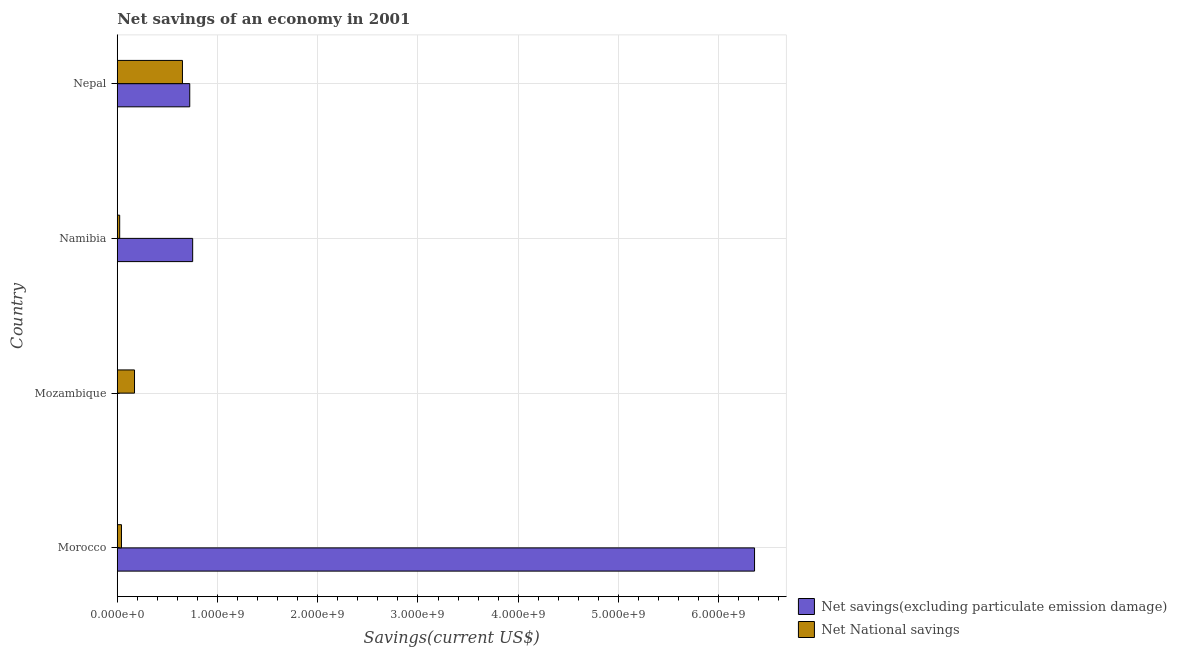Are the number of bars per tick equal to the number of legend labels?
Offer a very short reply. No. Are the number of bars on each tick of the Y-axis equal?
Make the answer very short. No. How many bars are there on the 1st tick from the bottom?
Your answer should be very brief. 2. What is the label of the 2nd group of bars from the top?
Ensure brevity in your answer.  Namibia. In how many cases, is the number of bars for a given country not equal to the number of legend labels?
Your response must be concise. 1. Across all countries, what is the maximum net savings(excluding particulate emission damage)?
Your response must be concise. 6.36e+09. Across all countries, what is the minimum net national savings?
Keep it short and to the point. 2.40e+07. In which country was the net national savings maximum?
Provide a succinct answer. Nepal. What is the total net savings(excluding particulate emission damage) in the graph?
Offer a terse response. 7.83e+09. What is the difference between the net national savings in Mozambique and that in Nepal?
Provide a short and direct response. -4.78e+08. What is the difference between the net savings(excluding particulate emission damage) in Namibia and the net national savings in Morocco?
Offer a very short reply. 7.11e+08. What is the average net savings(excluding particulate emission damage) per country?
Your answer should be very brief. 1.96e+09. What is the difference between the net savings(excluding particulate emission damage) and net national savings in Morocco?
Your response must be concise. 6.32e+09. What is the ratio of the net national savings in Namibia to that in Nepal?
Ensure brevity in your answer.  0.04. Is the difference between the net savings(excluding particulate emission damage) in Namibia and Nepal greater than the difference between the net national savings in Namibia and Nepal?
Provide a short and direct response. Yes. What is the difference between the highest and the second highest net national savings?
Your response must be concise. 4.78e+08. What is the difference between the highest and the lowest net savings(excluding particulate emission damage)?
Your response must be concise. 6.36e+09. Is the sum of the net national savings in Mozambique and Nepal greater than the maximum net savings(excluding particulate emission damage) across all countries?
Offer a very short reply. No. How many countries are there in the graph?
Your answer should be very brief. 4. What is the difference between two consecutive major ticks on the X-axis?
Your response must be concise. 1.00e+09. Are the values on the major ticks of X-axis written in scientific E-notation?
Your answer should be very brief. Yes. Where does the legend appear in the graph?
Keep it short and to the point. Bottom right. How many legend labels are there?
Your answer should be very brief. 2. How are the legend labels stacked?
Provide a short and direct response. Vertical. What is the title of the graph?
Make the answer very short. Net savings of an economy in 2001. Does "Foreign liabilities" appear as one of the legend labels in the graph?
Your response must be concise. No. What is the label or title of the X-axis?
Keep it short and to the point. Savings(current US$). What is the Savings(current US$) of Net savings(excluding particulate emission damage) in Morocco?
Your response must be concise. 6.36e+09. What is the Savings(current US$) of Net National savings in Morocco?
Give a very brief answer. 4.17e+07. What is the Savings(current US$) of Net savings(excluding particulate emission damage) in Mozambique?
Give a very brief answer. 0. What is the Savings(current US$) in Net National savings in Mozambique?
Your response must be concise. 1.72e+08. What is the Savings(current US$) in Net savings(excluding particulate emission damage) in Namibia?
Provide a short and direct response. 7.52e+08. What is the Savings(current US$) in Net National savings in Namibia?
Provide a short and direct response. 2.40e+07. What is the Savings(current US$) in Net savings(excluding particulate emission damage) in Nepal?
Your response must be concise. 7.23e+08. What is the Savings(current US$) of Net National savings in Nepal?
Ensure brevity in your answer.  6.50e+08. Across all countries, what is the maximum Savings(current US$) in Net savings(excluding particulate emission damage)?
Provide a succinct answer. 6.36e+09. Across all countries, what is the maximum Savings(current US$) of Net National savings?
Offer a very short reply. 6.50e+08. Across all countries, what is the minimum Savings(current US$) of Net National savings?
Give a very brief answer. 2.40e+07. What is the total Savings(current US$) in Net savings(excluding particulate emission damage) in the graph?
Keep it short and to the point. 7.83e+09. What is the total Savings(current US$) in Net National savings in the graph?
Ensure brevity in your answer.  8.88e+08. What is the difference between the Savings(current US$) in Net National savings in Morocco and that in Mozambique?
Your response must be concise. -1.30e+08. What is the difference between the Savings(current US$) of Net savings(excluding particulate emission damage) in Morocco and that in Namibia?
Offer a very short reply. 5.61e+09. What is the difference between the Savings(current US$) in Net National savings in Morocco and that in Namibia?
Provide a short and direct response. 1.77e+07. What is the difference between the Savings(current US$) of Net savings(excluding particulate emission damage) in Morocco and that in Nepal?
Provide a succinct answer. 5.64e+09. What is the difference between the Savings(current US$) in Net National savings in Morocco and that in Nepal?
Make the answer very short. -6.08e+08. What is the difference between the Savings(current US$) in Net National savings in Mozambique and that in Namibia?
Make the answer very short. 1.48e+08. What is the difference between the Savings(current US$) in Net National savings in Mozambique and that in Nepal?
Make the answer very short. -4.78e+08. What is the difference between the Savings(current US$) in Net savings(excluding particulate emission damage) in Namibia and that in Nepal?
Your answer should be compact. 2.92e+07. What is the difference between the Savings(current US$) of Net National savings in Namibia and that in Nepal?
Make the answer very short. -6.26e+08. What is the difference between the Savings(current US$) in Net savings(excluding particulate emission damage) in Morocco and the Savings(current US$) in Net National savings in Mozambique?
Keep it short and to the point. 6.19e+09. What is the difference between the Savings(current US$) in Net savings(excluding particulate emission damage) in Morocco and the Savings(current US$) in Net National savings in Namibia?
Give a very brief answer. 6.33e+09. What is the difference between the Savings(current US$) in Net savings(excluding particulate emission damage) in Morocco and the Savings(current US$) in Net National savings in Nepal?
Provide a succinct answer. 5.71e+09. What is the difference between the Savings(current US$) in Net savings(excluding particulate emission damage) in Namibia and the Savings(current US$) in Net National savings in Nepal?
Make the answer very short. 1.02e+08. What is the average Savings(current US$) in Net savings(excluding particulate emission damage) per country?
Give a very brief answer. 1.96e+09. What is the average Savings(current US$) of Net National savings per country?
Make the answer very short. 2.22e+08. What is the difference between the Savings(current US$) in Net savings(excluding particulate emission damage) and Savings(current US$) in Net National savings in Morocco?
Your response must be concise. 6.32e+09. What is the difference between the Savings(current US$) of Net savings(excluding particulate emission damage) and Savings(current US$) of Net National savings in Namibia?
Offer a terse response. 7.28e+08. What is the difference between the Savings(current US$) in Net savings(excluding particulate emission damage) and Savings(current US$) in Net National savings in Nepal?
Your answer should be compact. 7.29e+07. What is the ratio of the Savings(current US$) of Net National savings in Morocco to that in Mozambique?
Offer a terse response. 0.24. What is the ratio of the Savings(current US$) in Net savings(excluding particulate emission damage) in Morocco to that in Namibia?
Provide a short and direct response. 8.45. What is the ratio of the Savings(current US$) in Net National savings in Morocco to that in Namibia?
Keep it short and to the point. 1.74. What is the ratio of the Savings(current US$) in Net savings(excluding particulate emission damage) in Morocco to that in Nepal?
Your answer should be very brief. 8.79. What is the ratio of the Savings(current US$) of Net National savings in Morocco to that in Nepal?
Ensure brevity in your answer.  0.06. What is the ratio of the Savings(current US$) in Net National savings in Mozambique to that in Namibia?
Your answer should be compact. 7.16. What is the ratio of the Savings(current US$) in Net National savings in Mozambique to that in Nepal?
Ensure brevity in your answer.  0.26. What is the ratio of the Savings(current US$) of Net savings(excluding particulate emission damage) in Namibia to that in Nepal?
Your answer should be very brief. 1.04. What is the ratio of the Savings(current US$) in Net National savings in Namibia to that in Nepal?
Your response must be concise. 0.04. What is the difference between the highest and the second highest Savings(current US$) of Net savings(excluding particulate emission damage)?
Give a very brief answer. 5.61e+09. What is the difference between the highest and the second highest Savings(current US$) in Net National savings?
Keep it short and to the point. 4.78e+08. What is the difference between the highest and the lowest Savings(current US$) of Net savings(excluding particulate emission damage)?
Make the answer very short. 6.36e+09. What is the difference between the highest and the lowest Savings(current US$) in Net National savings?
Ensure brevity in your answer.  6.26e+08. 